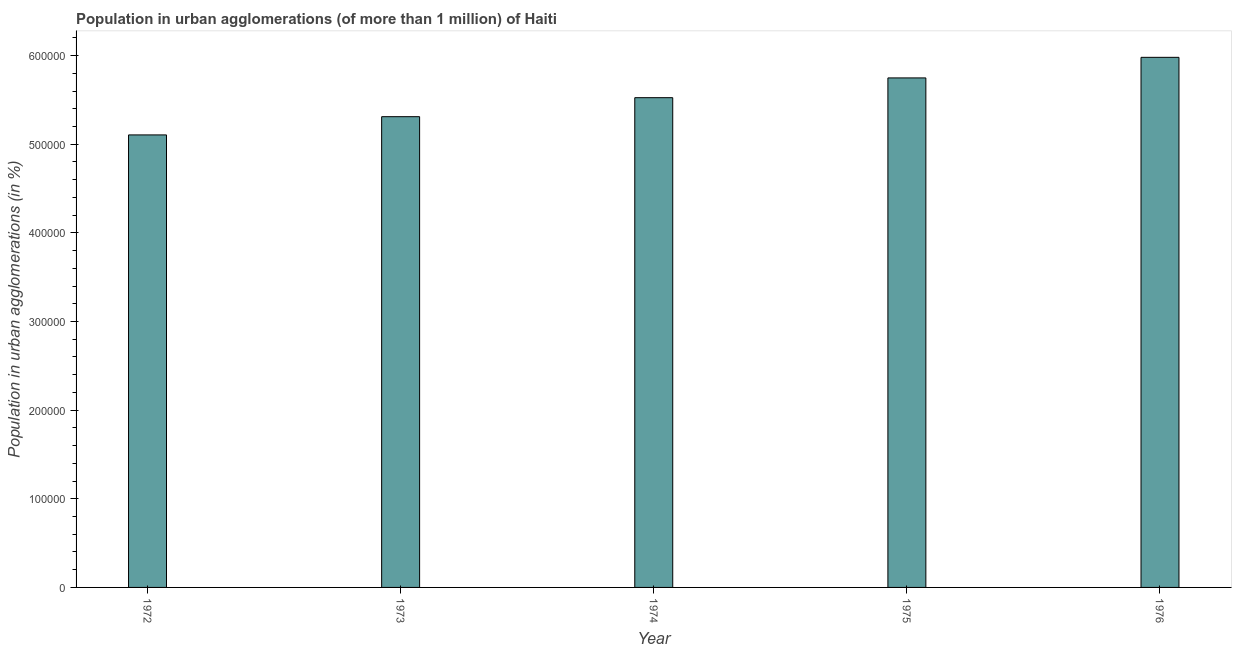Does the graph contain any zero values?
Provide a succinct answer. No. Does the graph contain grids?
Offer a terse response. No. What is the title of the graph?
Make the answer very short. Population in urban agglomerations (of more than 1 million) of Haiti. What is the label or title of the Y-axis?
Make the answer very short. Population in urban agglomerations (in %). What is the population in urban agglomerations in 1972?
Give a very brief answer. 5.11e+05. Across all years, what is the maximum population in urban agglomerations?
Your answer should be compact. 5.98e+05. Across all years, what is the minimum population in urban agglomerations?
Give a very brief answer. 5.11e+05. In which year was the population in urban agglomerations maximum?
Your answer should be very brief. 1976. In which year was the population in urban agglomerations minimum?
Offer a very short reply. 1972. What is the sum of the population in urban agglomerations?
Offer a very short reply. 2.77e+06. What is the difference between the population in urban agglomerations in 1974 and 1976?
Your response must be concise. -4.55e+04. What is the average population in urban agglomerations per year?
Ensure brevity in your answer.  5.53e+05. What is the median population in urban agglomerations?
Offer a terse response. 5.53e+05. Do a majority of the years between 1974 and 1973 (inclusive) have population in urban agglomerations greater than 140000 %?
Give a very brief answer. No. What is the ratio of the population in urban agglomerations in 1973 to that in 1975?
Your response must be concise. 0.92. What is the difference between the highest and the second highest population in urban agglomerations?
Your response must be concise. 2.32e+04. What is the difference between the highest and the lowest population in urban agglomerations?
Offer a very short reply. 8.75e+04. What is the difference between two consecutive major ticks on the Y-axis?
Ensure brevity in your answer.  1.00e+05. What is the Population in urban agglomerations (in %) in 1972?
Provide a succinct answer. 5.11e+05. What is the Population in urban agglomerations (in %) of 1973?
Your answer should be very brief. 5.31e+05. What is the Population in urban agglomerations (in %) in 1974?
Make the answer very short. 5.53e+05. What is the Population in urban agglomerations (in %) of 1975?
Ensure brevity in your answer.  5.75e+05. What is the Population in urban agglomerations (in %) in 1976?
Offer a very short reply. 5.98e+05. What is the difference between the Population in urban agglomerations (in %) in 1972 and 1973?
Your response must be concise. -2.06e+04. What is the difference between the Population in urban agglomerations (in %) in 1972 and 1974?
Provide a succinct answer. -4.20e+04. What is the difference between the Population in urban agglomerations (in %) in 1972 and 1975?
Provide a succinct answer. -6.43e+04. What is the difference between the Population in urban agglomerations (in %) in 1972 and 1976?
Offer a terse response. -8.75e+04. What is the difference between the Population in urban agglomerations (in %) in 1973 and 1974?
Keep it short and to the point. -2.14e+04. What is the difference between the Population in urban agglomerations (in %) in 1973 and 1975?
Give a very brief answer. -4.37e+04. What is the difference between the Population in urban agglomerations (in %) in 1973 and 1976?
Your answer should be compact. -6.70e+04. What is the difference between the Population in urban agglomerations (in %) in 1974 and 1975?
Your response must be concise. -2.23e+04. What is the difference between the Population in urban agglomerations (in %) in 1974 and 1976?
Make the answer very short. -4.55e+04. What is the difference between the Population in urban agglomerations (in %) in 1975 and 1976?
Provide a short and direct response. -2.32e+04. What is the ratio of the Population in urban agglomerations (in %) in 1972 to that in 1974?
Your answer should be very brief. 0.92. What is the ratio of the Population in urban agglomerations (in %) in 1972 to that in 1975?
Keep it short and to the point. 0.89. What is the ratio of the Population in urban agglomerations (in %) in 1972 to that in 1976?
Provide a succinct answer. 0.85. What is the ratio of the Population in urban agglomerations (in %) in 1973 to that in 1974?
Your answer should be very brief. 0.96. What is the ratio of the Population in urban agglomerations (in %) in 1973 to that in 1975?
Your response must be concise. 0.92. What is the ratio of the Population in urban agglomerations (in %) in 1973 to that in 1976?
Offer a terse response. 0.89. What is the ratio of the Population in urban agglomerations (in %) in 1974 to that in 1976?
Provide a succinct answer. 0.92. 